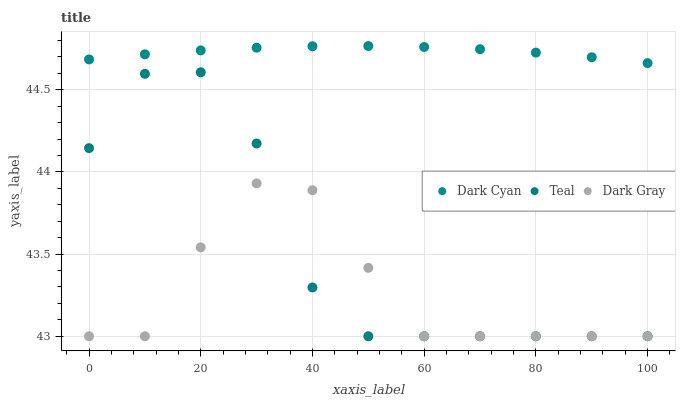Does Dark Gray have the minimum area under the curve?
Answer yes or no. Yes. Does Dark Cyan have the maximum area under the curve?
Answer yes or no. Yes. Does Teal have the minimum area under the curve?
Answer yes or no. No. Does Teal have the maximum area under the curve?
Answer yes or no. No. Is Dark Cyan the smoothest?
Answer yes or no. Yes. Is Teal the roughest?
Answer yes or no. Yes. Is Dark Gray the smoothest?
Answer yes or no. No. Is Dark Gray the roughest?
Answer yes or no. No. Does Dark Gray have the lowest value?
Answer yes or no. Yes. Does Dark Cyan have the highest value?
Answer yes or no. Yes. Does Teal have the highest value?
Answer yes or no. No. Is Teal less than Dark Cyan?
Answer yes or no. Yes. Is Dark Cyan greater than Teal?
Answer yes or no. Yes. Does Dark Gray intersect Teal?
Answer yes or no. Yes. Is Dark Gray less than Teal?
Answer yes or no. No. Is Dark Gray greater than Teal?
Answer yes or no. No. Does Teal intersect Dark Cyan?
Answer yes or no. No. 